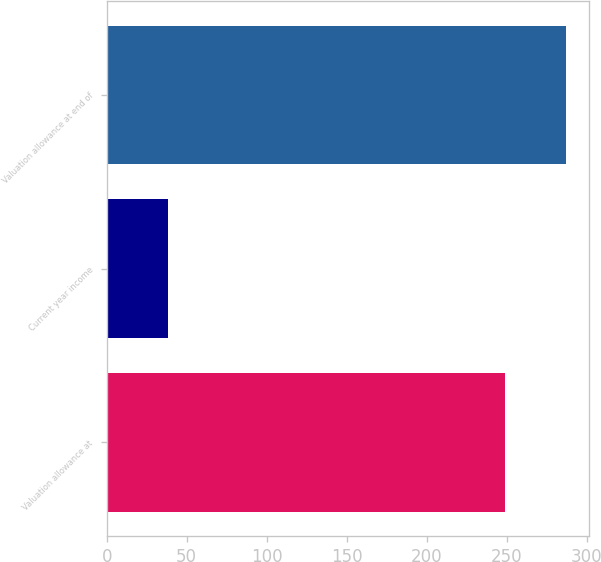Convert chart to OTSL. <chart><loc_0><loc_0><loc_500><loc_500><bar_chart><fcel>Valuation allowance at<fcel>Current year income<fcel>Valuation allowance at end of<nl><fcel>249<fcel>38<fcel>287<nl></chart> 